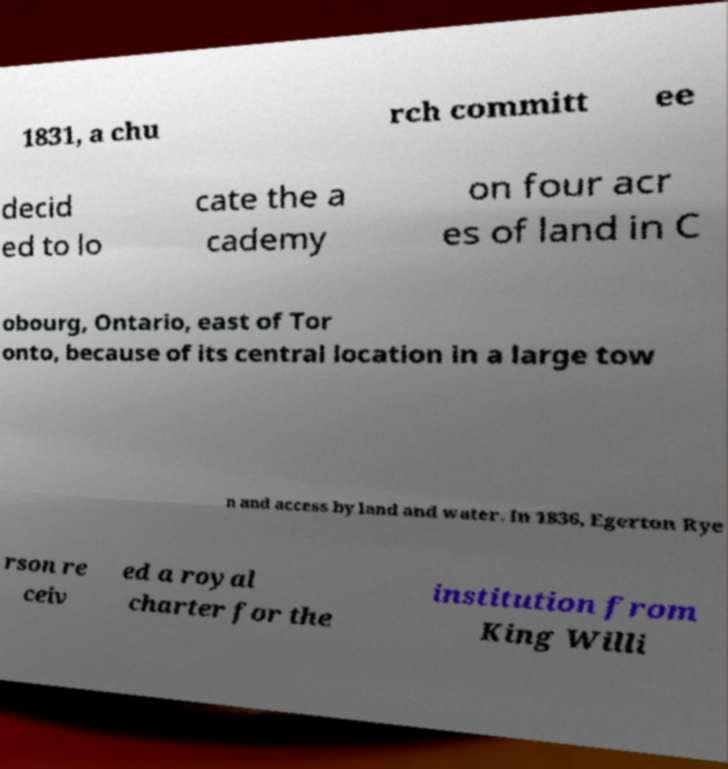For documentation purposes, I need the text within this image transcribed. Could you provide that? 1831, a chu rch committ ee decid ed to lo cate the a cademy on four acr es of land in C obourg, Ontario, east of Tor onto, because of its central location in a large tow n and access by land and water. In 1836, Egerton Rye rson re ceiv ed a royal charter for the institution from King Willi 